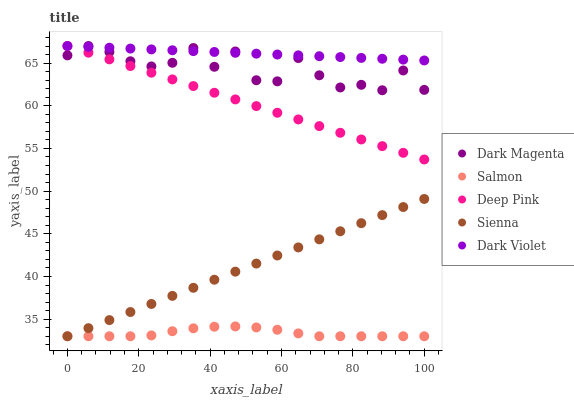Does Salmon have the minimum area under the curve?
Answer yes or no. Yes. Does Dark Violet have the maximum area under the curve?
Answer yes or no. Yes. Does Deep Pink have the minimum area under the curve?
Answer yes or no. No. Does Deep Pink have the maximum area under the curve?
Answer yes or no. No. Is Sienna the smoothest?
Answer yes or no. Yes. Is Dark Magenta the roughest?
Answer yes or no. Yes. Is Deep Pink the smoothest?
Answer yes or no. No. Is Deep Pink the roughest?
Answer yes or no. No. Does Sienna have the lowest value?
Answer yes or no. Yes. Does Deep Pink have the lowest value?
Answer yes or no. No. Does Dark Violet have the highest value?
Answer yes or no. Yes. Does Salmon have the highest value?
Answer yes or no. No. Is Sienna less than Dark Magenta?
Answer yes or no. Yes. Is Dark Magenta greater than Salmon?
Answer yes or no. Yes. Does Salmon intersect Sienna?
Answer yes or no. Yes. Is Salmon less than Sienna?
Answer yes or no. No. Is Salmon greater than Sienna?
Answer yes or no. No. Does Sienna intersect Dark Magenta?
Answer yes or no. No. 